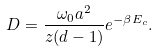Convert formula to latex. <formula><loc_0><loc_0><loc_500><loc_500>D = \frac { \omega _ { 0 } a ^ { 2 } } { z ( d - 1 ) } e ^ { - \beta E _ { c } } .</formula> 